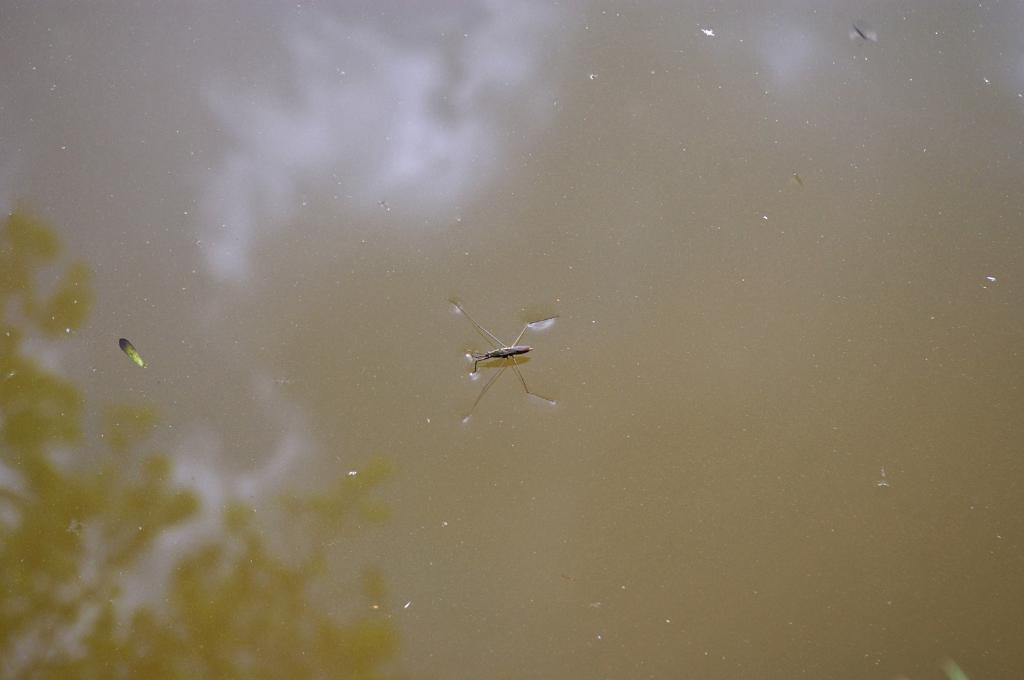What type of creature is in the image? There is an insect in the image. Where is the insect located? The insect is on the water. What else can be seen in the image besides the insect? There is a reflection of stems with leaves in the image. What type of street is visible in the image? There is no street present in the image; it features an insect on the water and a reflection of stems with leaves. 